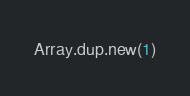<code> <loc_0><loc_0><loc_500><loc_500><_Ruby_>Array.dup.new(1)
</code> 